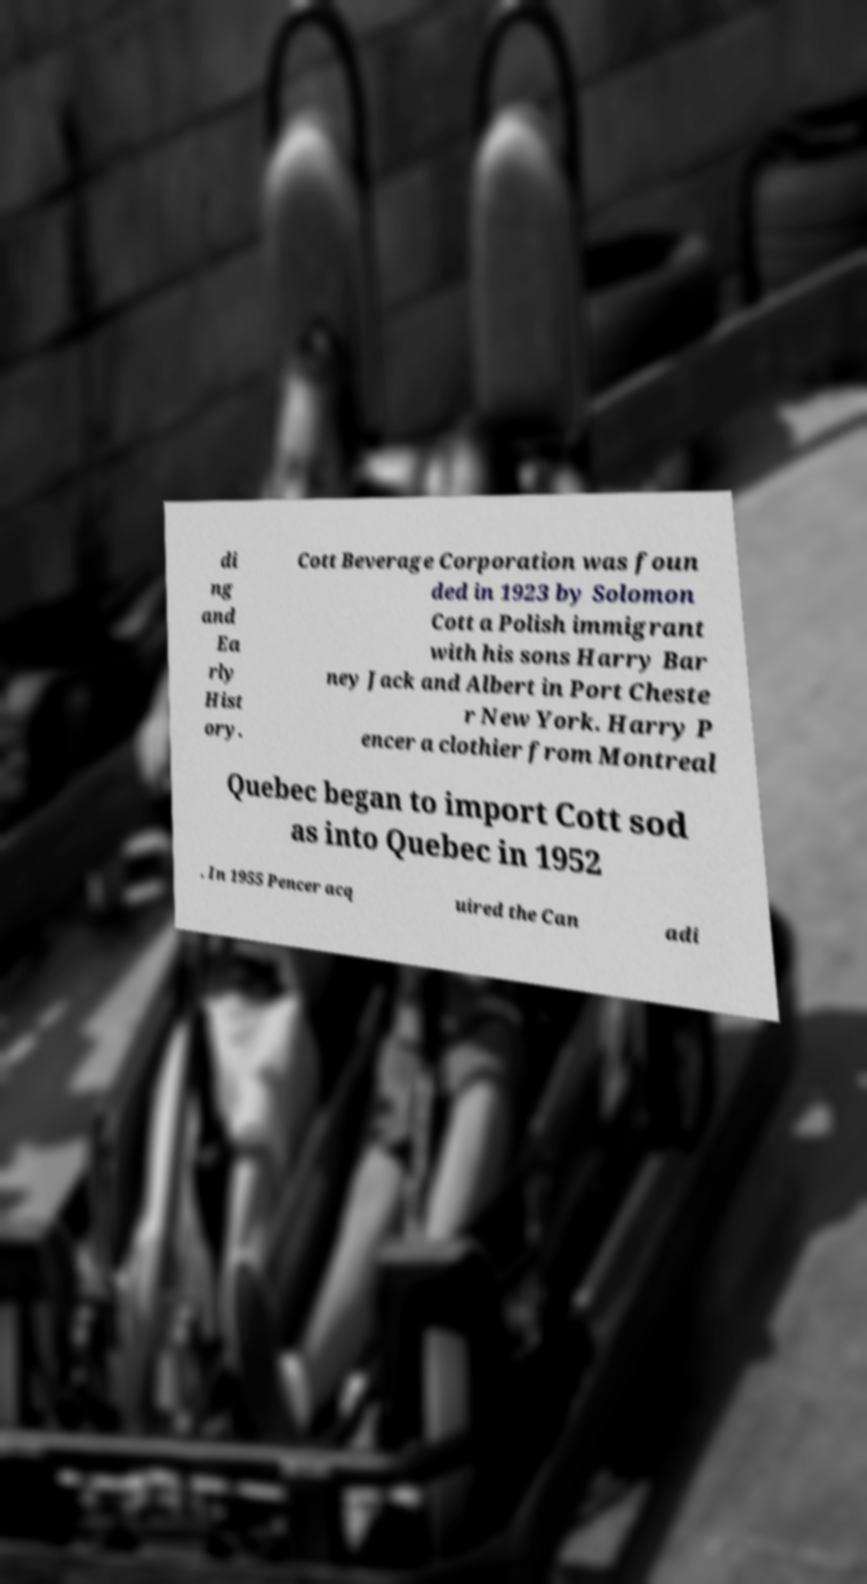I need the written content from this picture converted into text. Can you do that? di ng and Ea rly Hist ory. Cott Beverage Corporation was foun ded in 1923 by Solomon Cott a Polish immigrant with his sons Harry Bar ney Jack and Albert in Port Cheste r New York. Harry P encer a clothier from Montreal Quebec began to import Cott sod as into Quebec in 1952 . In 1955 Pencer acq uired the Can adi 